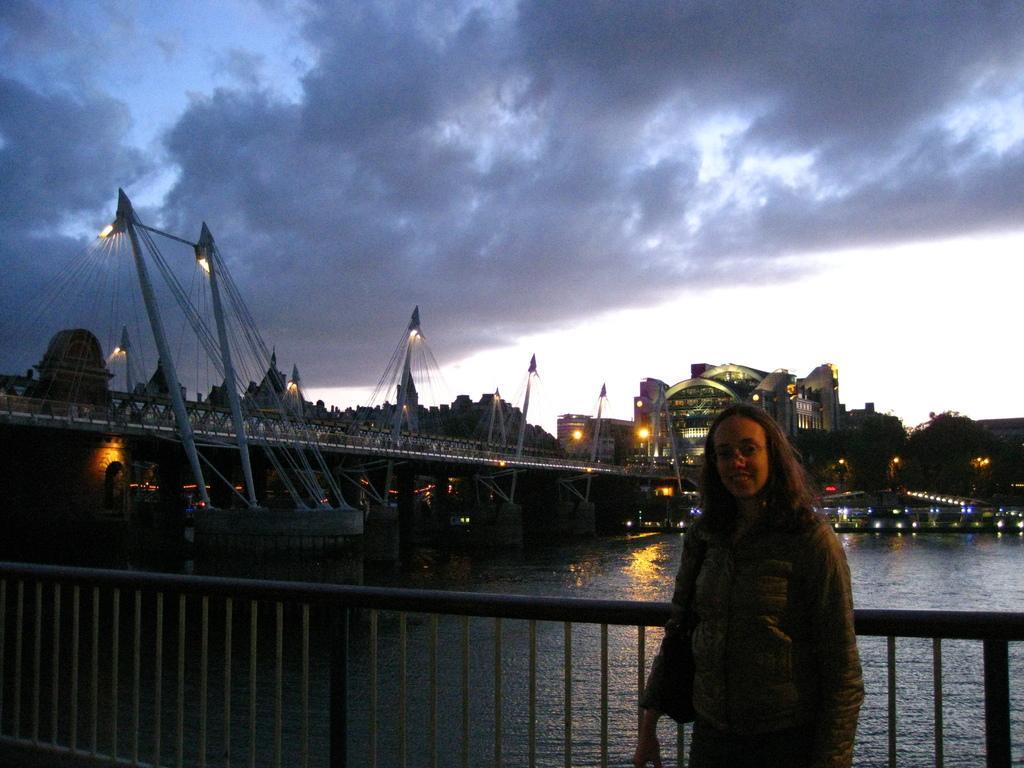Could you give a brief overview of what you see in this image? In this image I can see the person standing and wearing the dress and the bag. At the back of the person I can see the railing and water. In the background I can see the bridge and many light poles. I can also see the buildings, clouds and the sky in the back. 